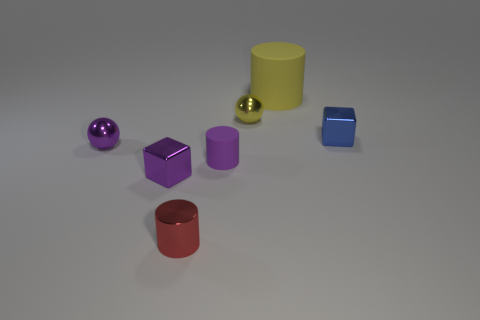Subtract all small cylinders. How many cylinders are left? 1 Add 2 yellow balls. How many objects exist? 9 Subtract all cubes. How many objects are left? 5 Subtract 2 cubes. How many cubes are left? 0 Add 7 purple cylinders. How many purple cylinders exist? 8 Subtract all purple cylinders. How many cylinders are left? 2 Subtract 0 green cylinders. How many objects are left? 7 Subtract all gray balls. Subtract all red cylinders. How many balls are left? 2 Subtract all cyan balls. How many yellow cylinders are left? 1 Subtract all red cylinders. Subtract all large cyan matte cylinders. How many objects are left? 6 